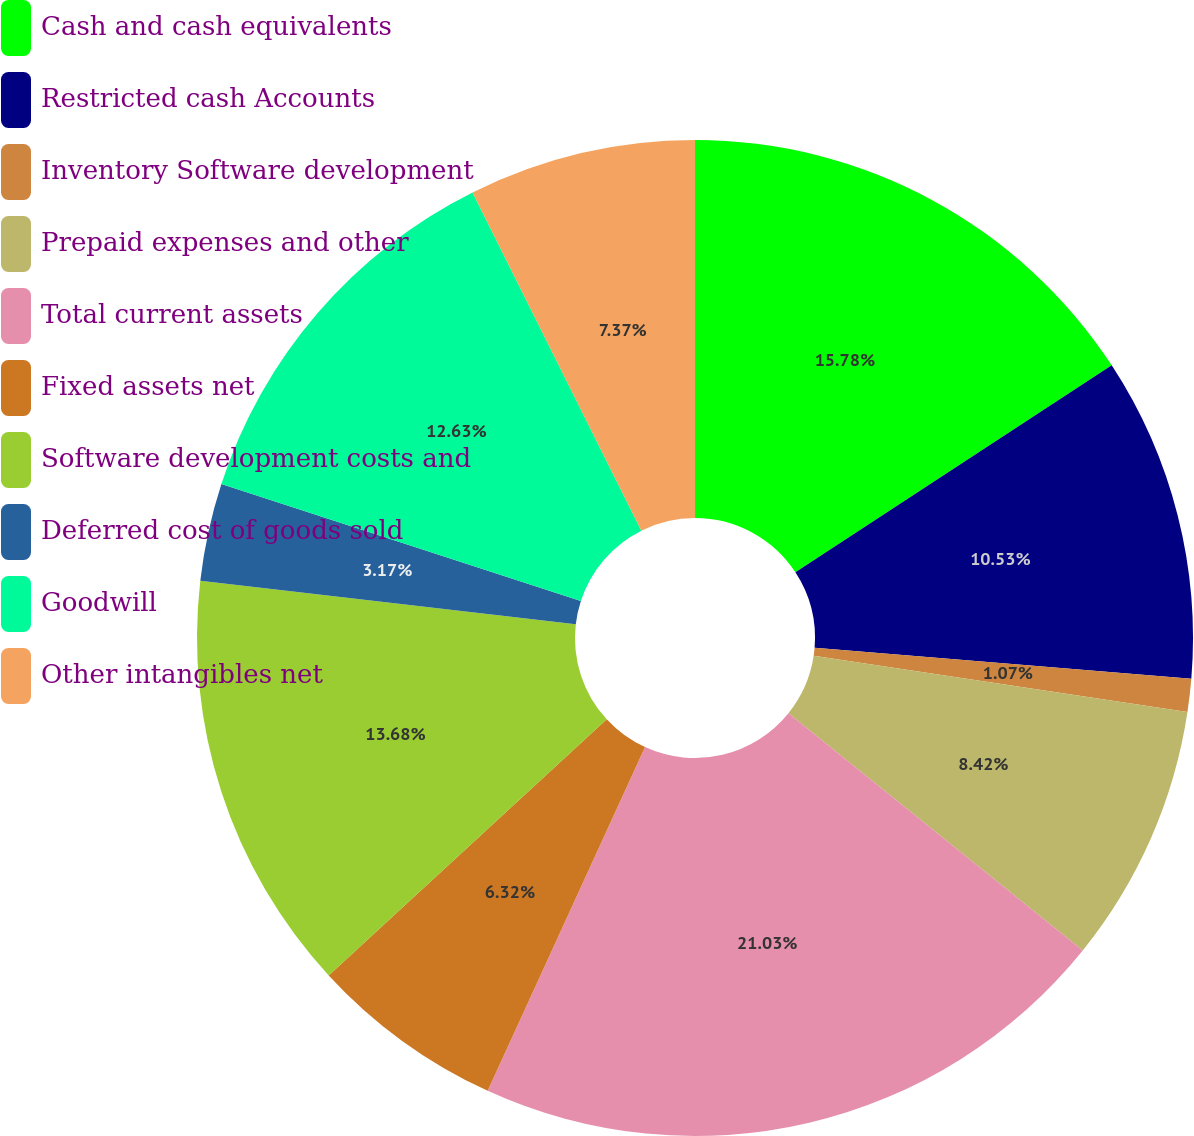Convert chart to OTSL. <chart><loc_0><loc_0><loc_500><loc_500><pie_chart><fcel>Cash and cash equivalents<fcel>Restricted cash Accounts<fcel>Inventory Software development<fcel>Prepaid expenses and other<fcel>Total current assets<fcel>Fixed assets net<fcel>Software development costs and<fcel>Deferred cost of goods sold<fcel>Goodwill<fcel>Other intangibles net<nl><fcel>15.78%<fcel>10.53%<fcel>1.07%<fcel>8.42%<fcel>21.04%<fcel>6.32%<fcel>13.68%<fcel>3.17%<fcel>12.63%<fcel>7.37%<nl></chart> 